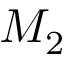<formula> <loc_0><loc_0><loc_500><loc_500>M _ { 2 }</formula> 